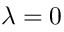Convert formula to latex. <formula><loc_0><loc_0><loc_500><loc_500>\lambda = 0</formula> 